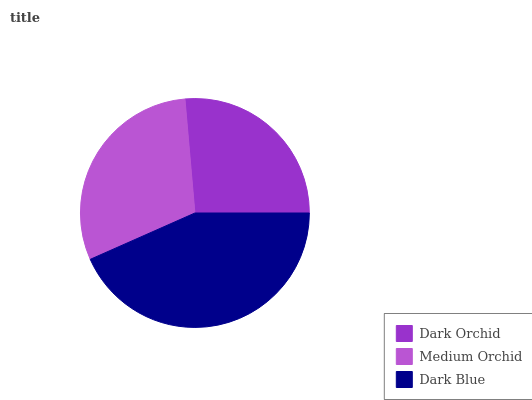Is Dark Orchid the minimum?
Answer yes or no. Yes. Is Dark Blue the maximum?
Answer yes or no. Yes. Is Medium Orchid the minimum?
Answer yes or no. No. Is Medium Orchid the maximum?
Answer yes or no. No. Is Medium Orchid greater than Dark Orchid?
Answer yes or no. Yes. Is Dark Orchid less than Medium Orchid?
Answer yes or no. Yes. Is Dark Orchid greater than Medium Orchid?
Answer yes or no. No. Is Medium Orchid less than Dark Orchid?
Answer yes or no. No. Is Medium Orchid the high median?
Answer yes or no. Yes. Is Medium Orchid the low median?
Answer yes or no. Yes. Is Dark Blue the high median?
Answer yes or no. No. Is Dark Blue the low median?
Answer yes or no. No. 